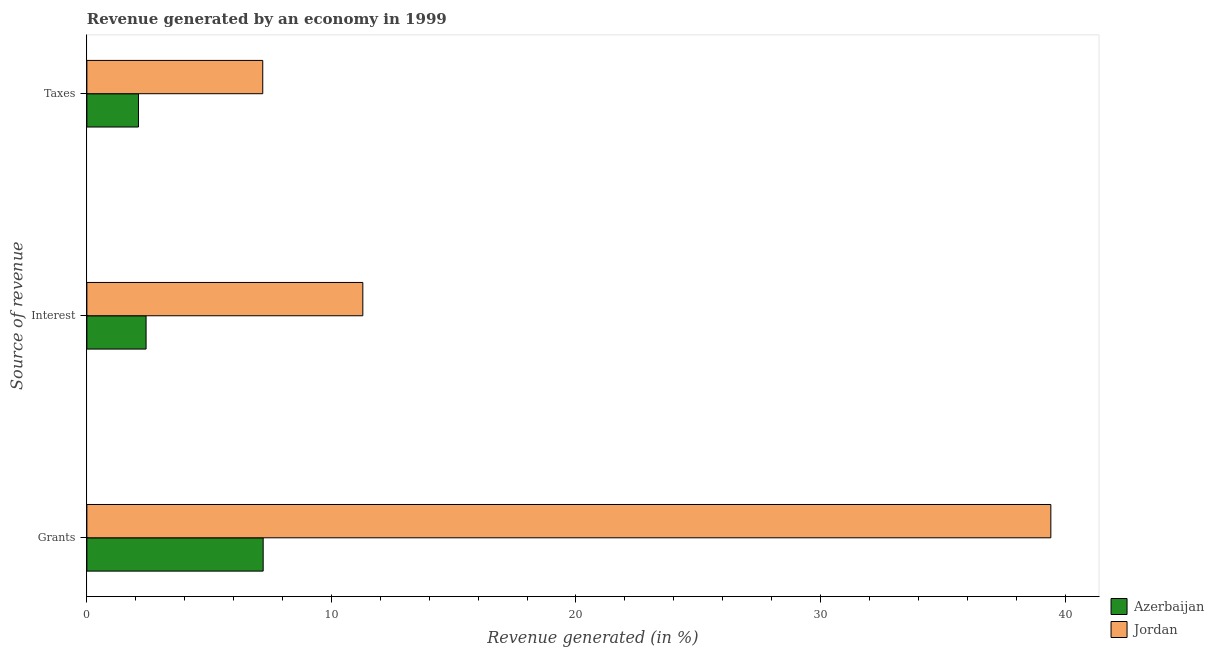How many different coloured bars are there?
Provide a succinct answer. 2. How many groups of bars are there?
Make the answer very short. 3. Are the number of bars per tick equal to the number of legend labels?
Offer a very short reply. Yes. Are the number of bars on each tick of the Y-axis equal?
Your answer should be very brief. Yes. What is the label of the 2nd group of bars from the top?
Give a very brief answer. Interest. What is the percentage of revenue generated by interest in Jordan?
Offer a terse response. 11.28. Across all countries, what is the maximum percentage of revenue generated by taxes?
Your response must be concise. 7.19. Across all countries, what is the minimum percentage of revenue generated by interest?
Provide a succinct answer. 2.42. In which country was the percentage of revenue generated by interest maximum?
Provide a short and direct response. Jordan. In which country was the percentage of revenue generated by taxes minimum?
Keep it short and to the point. Azerbaijan. What is the total percentage of revenue generated by taxes in the graph?
Offer a very short reply. 9.3. What is the difference between the percentage of revenue generated by grants in Azerbaijan and that in Jordan?
Offer a very short reply. -32.21. What is the difference between the percentage of revenue generated by grants in Jordan and the percentage of revenue generated by taxes in Azerbaijan?
Your answer should be compact. 37.31. What is the average percentage of revenue generated by grants per country?
Ensure brevity in your answer.  23.31. What is the difference between the percentage of revenue generated by taxes and percentage of revenue generated by grants in Azerbaijan?
Give a very brief answer. -5.1. What is the ratio of the percentage of revenue generated by interest in Jordan to that in Azerbaijan?
Your answer should be very brief. 4.66. Is the percentage of revenue generated by grants in Azerbaijan less than that in Jordan?
Offer a terse response. Yes. What is the difference between the highest and the second highest percentage of revenue generated by taxes?
Your answer should be compact. 5.08. What is the difference between the highest and the lowest percentage of revenue generated by taxes?
Offer a very short reply. 5.08. Is the sum of the percentage of revenue generated by interest in Jordan and Azerbaijan greater than the maximum percentage of revenue generated by grants across all countries?
Your response must be concise. No. What does the 2nd bar from the top in Grants represents?
Provide a succinct answer. Azerbaijan. What does the 2nd bar from the bottom in Taxes represents?
Ensure brevity in your answer.  Jordan. How many bars are there?
Your answer should be very brief. 6. Are all the bars in the graph horizontal?
Your answer should be compact. Yes. What is the difference between two consecutive major ticks on the X-axis?
Your answer should be compact. 10. Are the values on the major ticks of X-axis written in scientific E-notation?
Offer a very short reply. No. Does the graph contain grids?
Your answer should be very brief. No. How many legend labels are there?
Provide a succinct answer. 2. How are the legend labels stacked?
Offer a terse response. Vertical. What is the title of the graph?
Ensure brevity in your answer.  Revenue generated by an economy in 1999. What is the label or title of the X-axis?
Offer a terse response. Revenue generated (in %). What is the label or title of the Y-axis?
Provide a succinct answer. Source of revenue. What is the Revenue generated (in %) of Azerbaijan in Grants?
Offer a terse response. 7.21. What is the Revenue generated (in %) in Jordan in Grants?
Provide a short and direct response. 39.42. What is the Revenue generated (in %) of Azerbaijan in Interest?
Your response must be concise. 2.42. What is the Revenue generated (in %) of Jordan in Interest?
Provide a succinct answer. 11.28. What is the Revenue generated (in %) of Azerbaijan in Taxes?
Provide a short and direct response. 2.11. What is the Revenue generated (in %) in Jordan in Taxes?
Offer a terse response. 7.19. Across all Source of revenue, what is the maximum Revenue generated (in %) in Azerbaijan?
Keep it short and to the point. 7.21. Across all Source of revenue, what is the maximum Revenue generated (in %) of Jordan?
Make the answer very short. 39.42. Across all Source of revenue, what is the minimum Revenue generated (in %) in Azerbaijan?
Ensure brevity in your answer.  2.11. Across all Source of revenue, what is the minimum Revenue generated (in %) in Jordan?
Provide a short and direct response. 7.19. What is the total Revenue generated (in %) in Azerbaijan in the graph?
Your answer should be very brief. 11.74. What is the total Revenue generated (in %) of Jordan in the graph?
Offer a very short reply. 57.89. What is the difference between the Revenue generated (in %) of Azerbaijan in Grants and that in Interest?
Provide a short and direct response. 4.79. What is the difference between the Revenue generated (in %) of Jordan in Grants and that in Interest?
Provide a short and direct response. 28.13. What is the difference between the Revenue generated (in %) in Azerbaijan in Grants and that in Taxes?
Give a very brief answer. 5.1. What is the difference between the Revenue generated (in %) of Jordan in Grants and that in Taxes?
Your response must be concise. 32.23. What is the difference between the Revenue generated (in %) of Azerbaijan in Interest and that in Taxes?
Give a very brief answer. 0.31. What is the difference between the Revenue generated (in %) in Jordan in Interest and that in Taxes?
Offer a terse response. 4.09. What is the difference between the Revenue generated (in %) of Azerbaijan in Grants and the Revenue generated (in %) of Jordan in Interest?
Offer a terse response. -4.08. What is the difference between the Revenue generated (in %) in Azerbaijan in Grants and the Revenue generated (in %) in Jordan in Taxes?
Ensure brevity in your answer.  0.02. What is the difference between the Revenue generated (in %) in Azerbaijan in Interest and the Revenue generated (in %) in Jordan in Taxes?
Offer a very short reply. -4.77. What is the average Revenue generated (in %) of Azerbaijan per Source of revenue?
Give a very brief answer. 3.91. What is the average Revenue generated (in %) of Jordan per Source of revenue?
Ensure brevity in your answer.  19.3. What is the difference between the Revenue generated (in %) of Azerbaijan and Revenue generated (in %) of Jordan in Grants?
Provide a succinct answer. -32.21. What is the difference between the Revenue generated (in %) in Azerbaijan and Revenue generated (in %) in Jordan in Interest?
Make the answer very short. -8.86. What is the difference between the Revenue generated (in %) in Azerbaijan and Revenue generated (in %) in Jordan in Taxes?
Offer a terse response. -5.08. What is the ratio of the Revenue generated (in %) in Azerbaijan in Grants to that in Interest?
Ensure brevity in your answer.  2.98. What is the ratio of the Revenue generated (in %) of Jordan in Grants to that in Interest?
Ensure brevity in your answer.  3.49. What is the ratio of the Revenue generated (in %) of Azerbaijan in Grants to that in Taxes?
Offer a terse response. 3.42. What is the ratio of the Revenue generated (in %) of Jordan in Grants to that in Taxes?
Ensure brevity in your answer.  5.48. What is the ratio of the Revenue generated (in %) of Azerbaijan in Interest to that in Taxes?
Provide a short and direct response. 1.15. What is the ratio of the Revenue generated (in %) in Jordan in Interest to that in Taxes?
Offer a very short reply. 1.57. What is the difference between the highest and the second highest Revenue generated (in %) of Azerbaijan?
Give a very brief answer. 4.79. What is the difference between the highest and the second highest Revenue generated (in %) in Jordan?
Provide a succinct answer. 28.13. What is the difference between the highest and the lowest Revenue generated (in %) in Azerbaijan?
Your answer should be very brief. 5.1. What is the difference between the highest and the lowest Revenue generated (in %) in Jordan?
Offer a terse response. 32.23. 